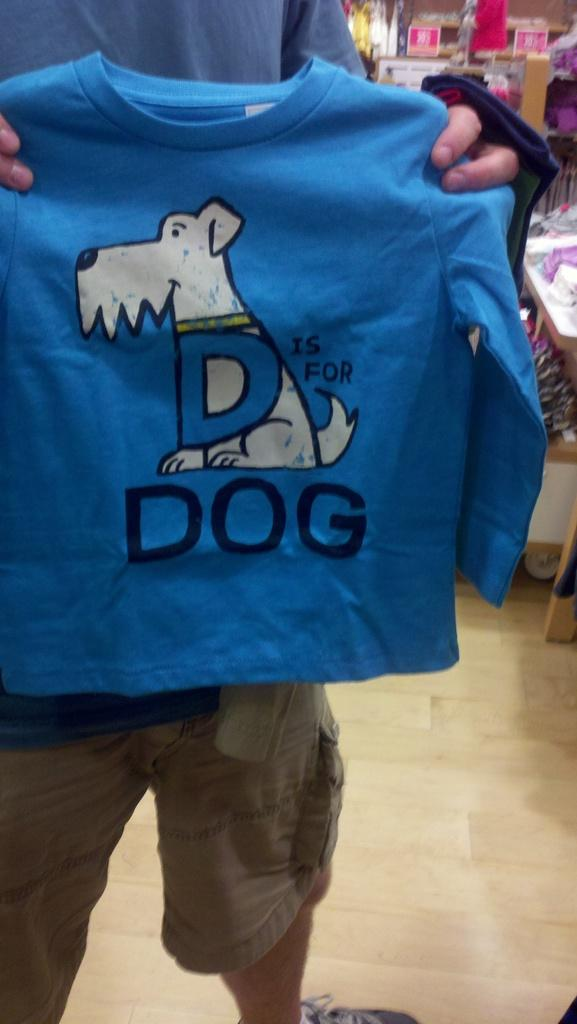What is the person in the image doing? The person is standing in the image and holding clothes. What else can be seen in the image besides the person? There are clothes and objects visible in the background of the image. What type of objects can be seen in the background? There are boards present in the background of the image. What month is it in the image? The month cannot be determined from the image, as there is no information about the time of year or any specific calendar dates. --- Facts: 1. There is a person sitting on a chair in the image. 2. The person is holding a book. 3. The book has a title on the cover. 4. There is a table next to the chair. 5. There is a lamp on the table. Absurd Topics: parrot, ocean, bicycle Conversation: What is the person in the image doing? The person is sitting on a chair in the image and holding a book. What can be seen on the cover of the book? The book has a title on the cover. What is located next to the chair in the image? There is a table next to the chair in the image. What is on the table? There is a lamp on the table. Reasoning: Let's think step by step in order to produce the conversation. We start by identifying the main subject in the image, which is the person sitting on a chair and holding a book. Then, we expand the conversation to include other items that are also visible, such as the book's title, the table, and the lamp. Each question is designed to elicit a specific detail about the image that is known from the provided facts. Absurd Question/Answer: Can you see a parrot sitting on the person's shoulder in the image? No, there is no parrot present in the image. 